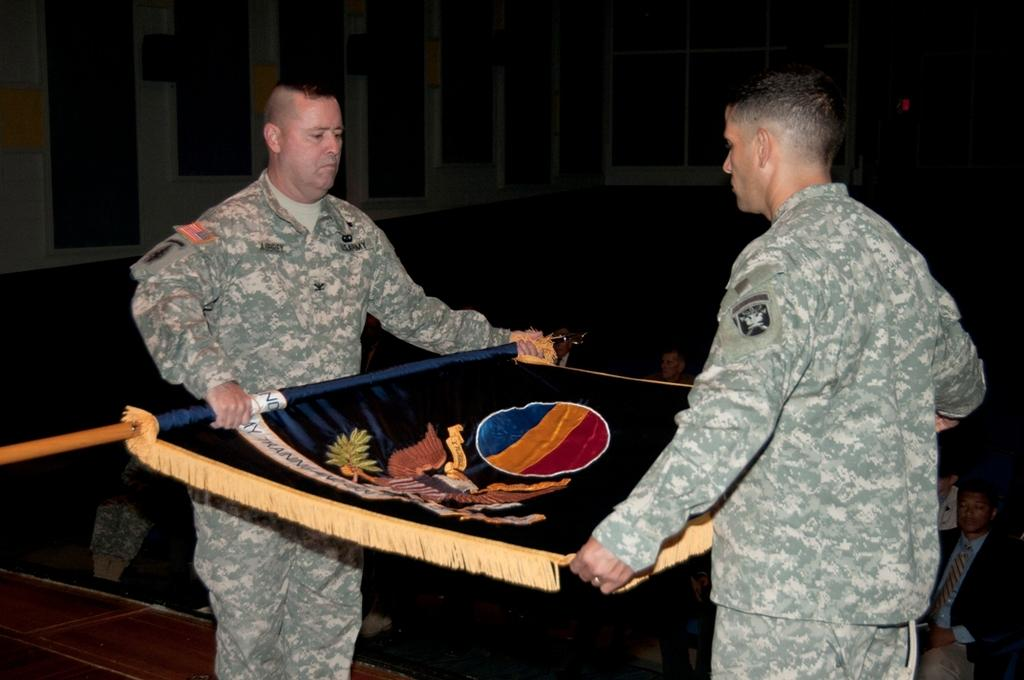What are the people in the image doing with the flag? There are people holding a flag in the image. What else can be seen in the image besides the flag? There are people sitting in the image. What type of pet can be seen walking on the trail in the image? There is no pet or trail present in the image. What story is being told by the people holding the flag in the image? There is no story being told in the image; it simply shows people holding a flag and sitting. 